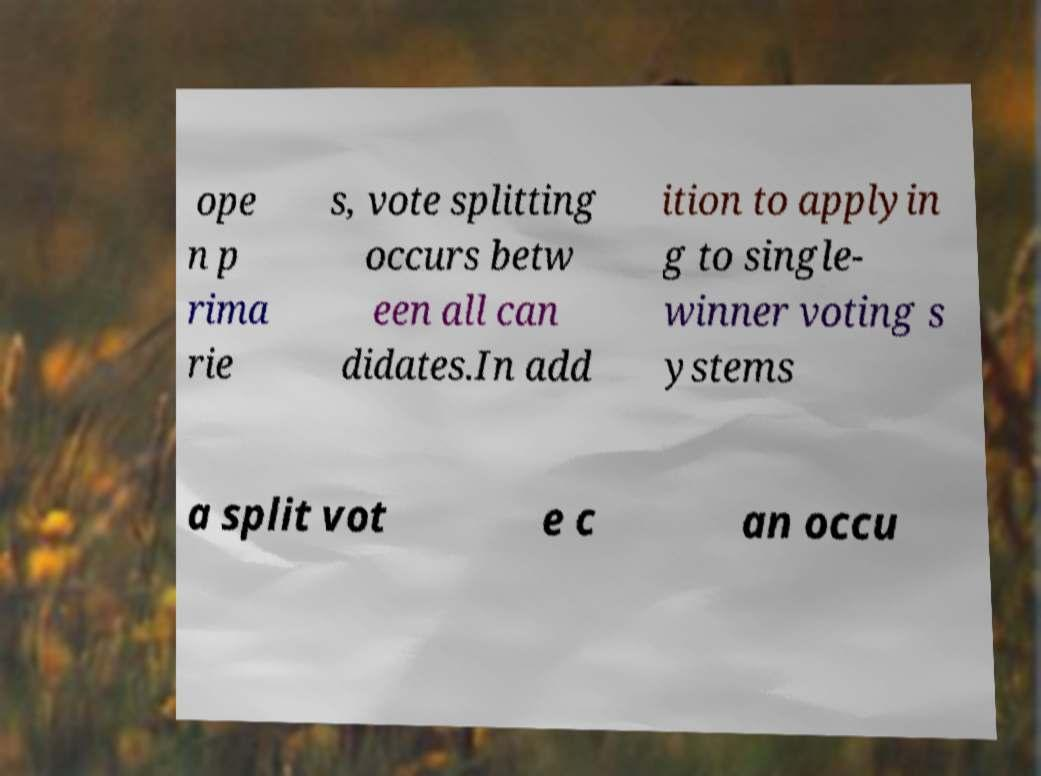Could the background scenery in the image relate to the text on voting? The background of the image, featuring a blurry nature scene, might symbolize the complexity and lack of clarity that can come from the voting scenarios like those described in the text. It could metaphorically represent how political landscapes can be as diverse and variable as natural ones, reflecting the varying opinions and outcomes in open primaries and split vote situations. 